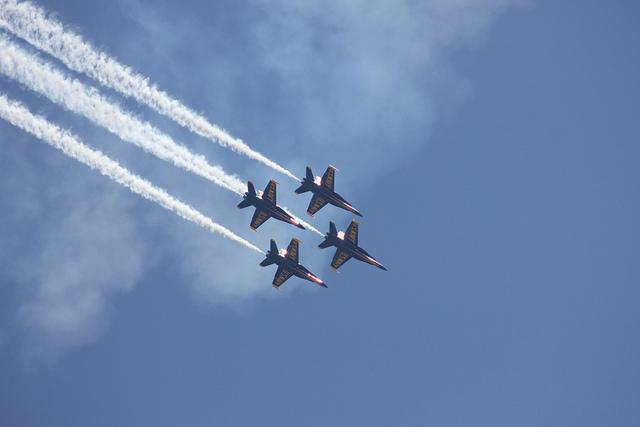How many planes are there?
Give a very brief answer. 4. How many streams of smoke are there?
Give a very brief answer. 3. How many airplanes are in flight?
Give a very brief answer. 4. How many men are in this picture?
Give a very brief answer. 0. 